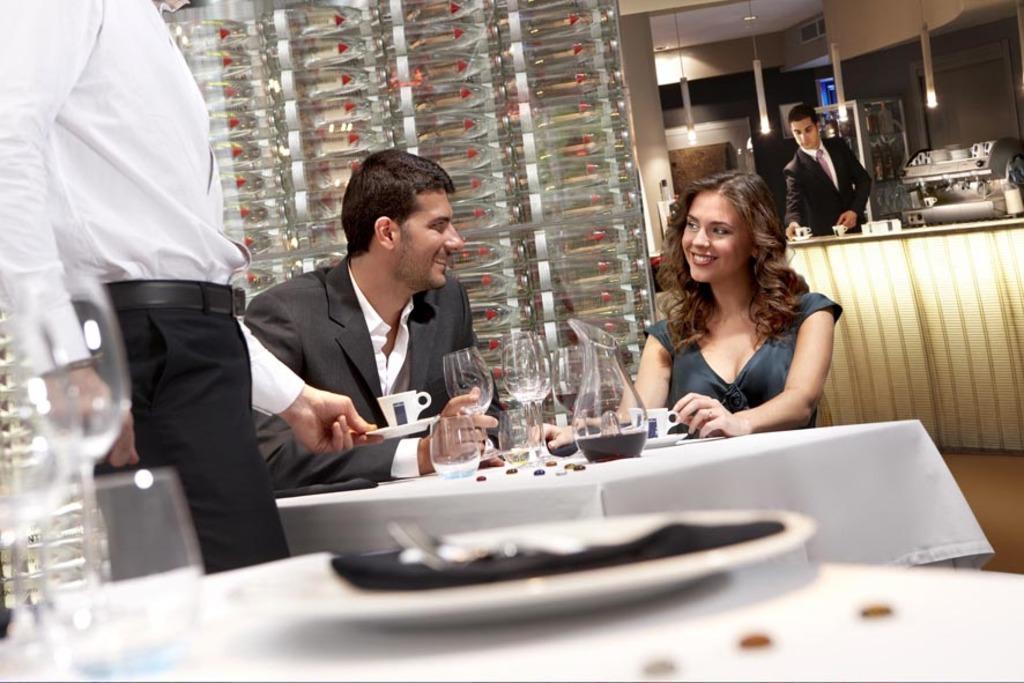Could you give a brief overview of what you see in this image? In this image I can see two people are sitting in front of the table. On the table there is a flask and the glasses. To the left there is a person standing and holding the cup. In the back ground there is another person standing and holding the cup. 